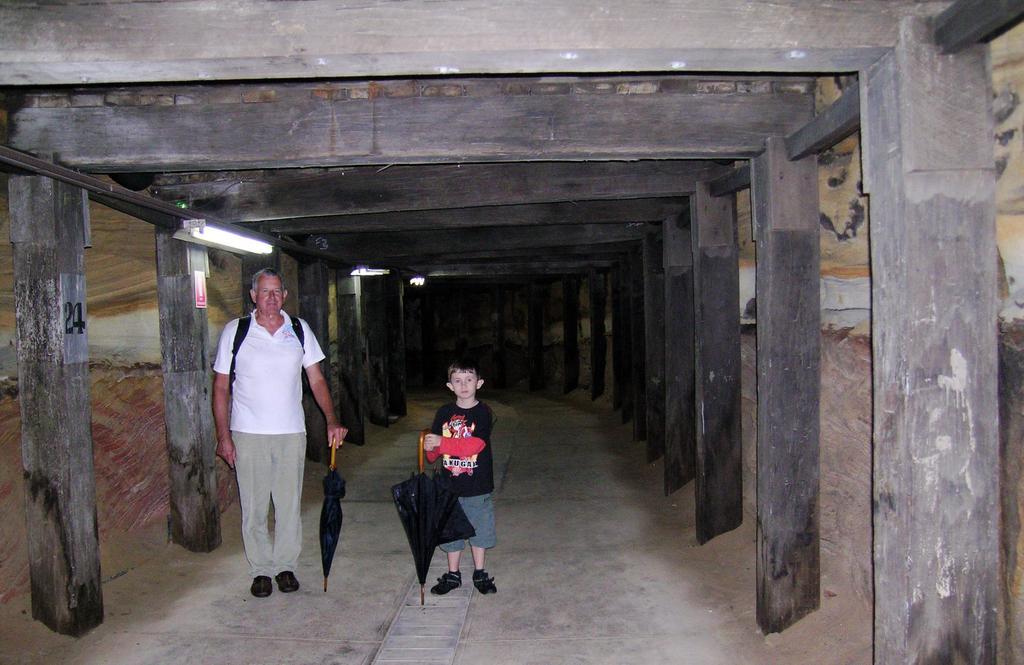Could you give a brief overview of what you see in this image? In this image we can see a man and a boy. We can also see that both of them are holding an umbrella and the man is also wearing a bag. In the background we can see 3 tube lights and we can also see that there is a pillar on which it says number 24. 